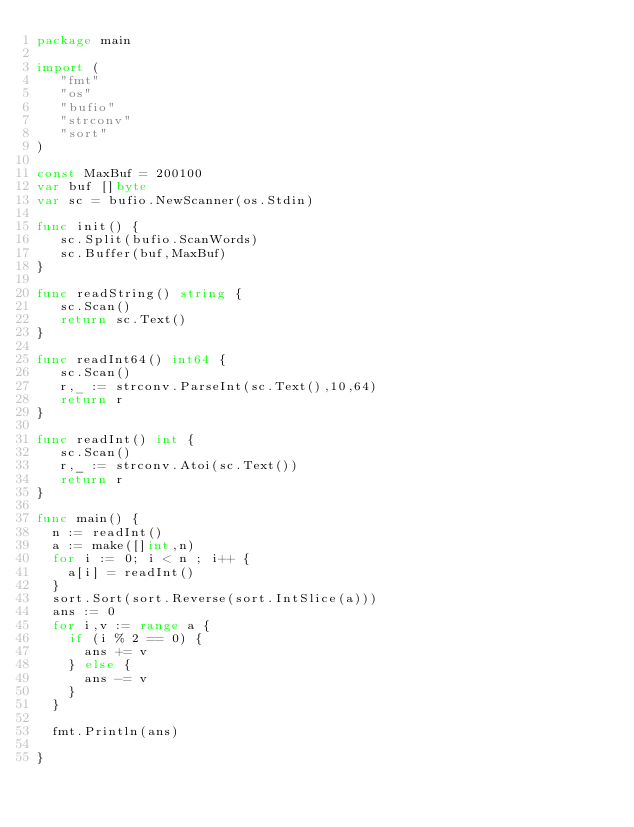Convert code to text. <code><loc_0><loc_0><loc_500><loc_500><_Go_>package main

import (
   "fmt"
   "os"
   "bufio"
   "strconv"
   "sort"
)

const MaxBuf = 200100
var buf []byte
var sc = bufio.NewScanner(os.Stdin)

func init() {
   sc.Split(bufio.ScanWords)
   sc.Buffer(buf,MaxBuf)
}

func readString() string {
   sc.Scan()
   return sc.Text()
}

func readInt64() int64 {
   sc.Scan()
   r,_ := strconv.ParseInt(sc.Text(),10,64)
   return r
}

func readInt() int {
   sc.Scan()
   r,_ := strconv.Atoi(sc.Text())
   return r
}

func main() {
	n := readInt()
	a := make([]int,n)
	for i := 0; i < n ; i++ {
		a[i] = readInt()
	}
	sort.Sort(sort.Reverse(sort.IntSlice(a)))
	ans := 0
	for i,v := range a {
		if (i % 2 == 0) {
			ans += v
		} else {
			ans -= v
		}
	}

	fmt.Println(ans)
	
}</code> 